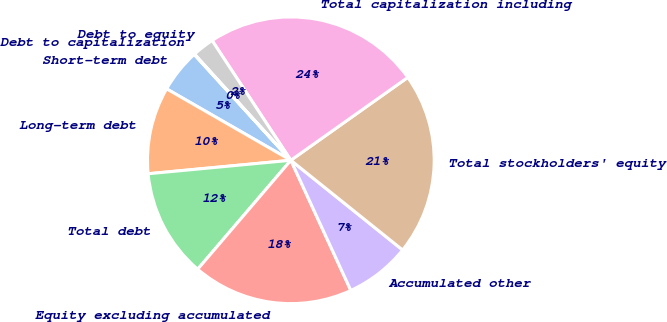<chart> <loc_0><loc_0><loc_500><loc_500><pie_chart><fcel>Short-term debt<fcel>Long-term debt<fcel>Total debt<fcel>Equity excluding accumulated<fcel>Accumulated other<fcel>Total stockholders' equity<fcel>Total capitalization including<fcel>Debt to equity<fcel>Debt to capitalization<nl><fcel>4.92%<fcel>9.8%<fcel>12.24%<fcel>18.13%<fcel>7.36%<fcel>20.57%<fcel>24.44%<fcel>2.48%<fcel>0.04%<nl></chart> 